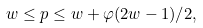<formula> <loc_0><loc_0><loc_500><loc_500>w \leq p \leq w + \varphi ( 2 w - 1 ) / 2 ,</formula> 